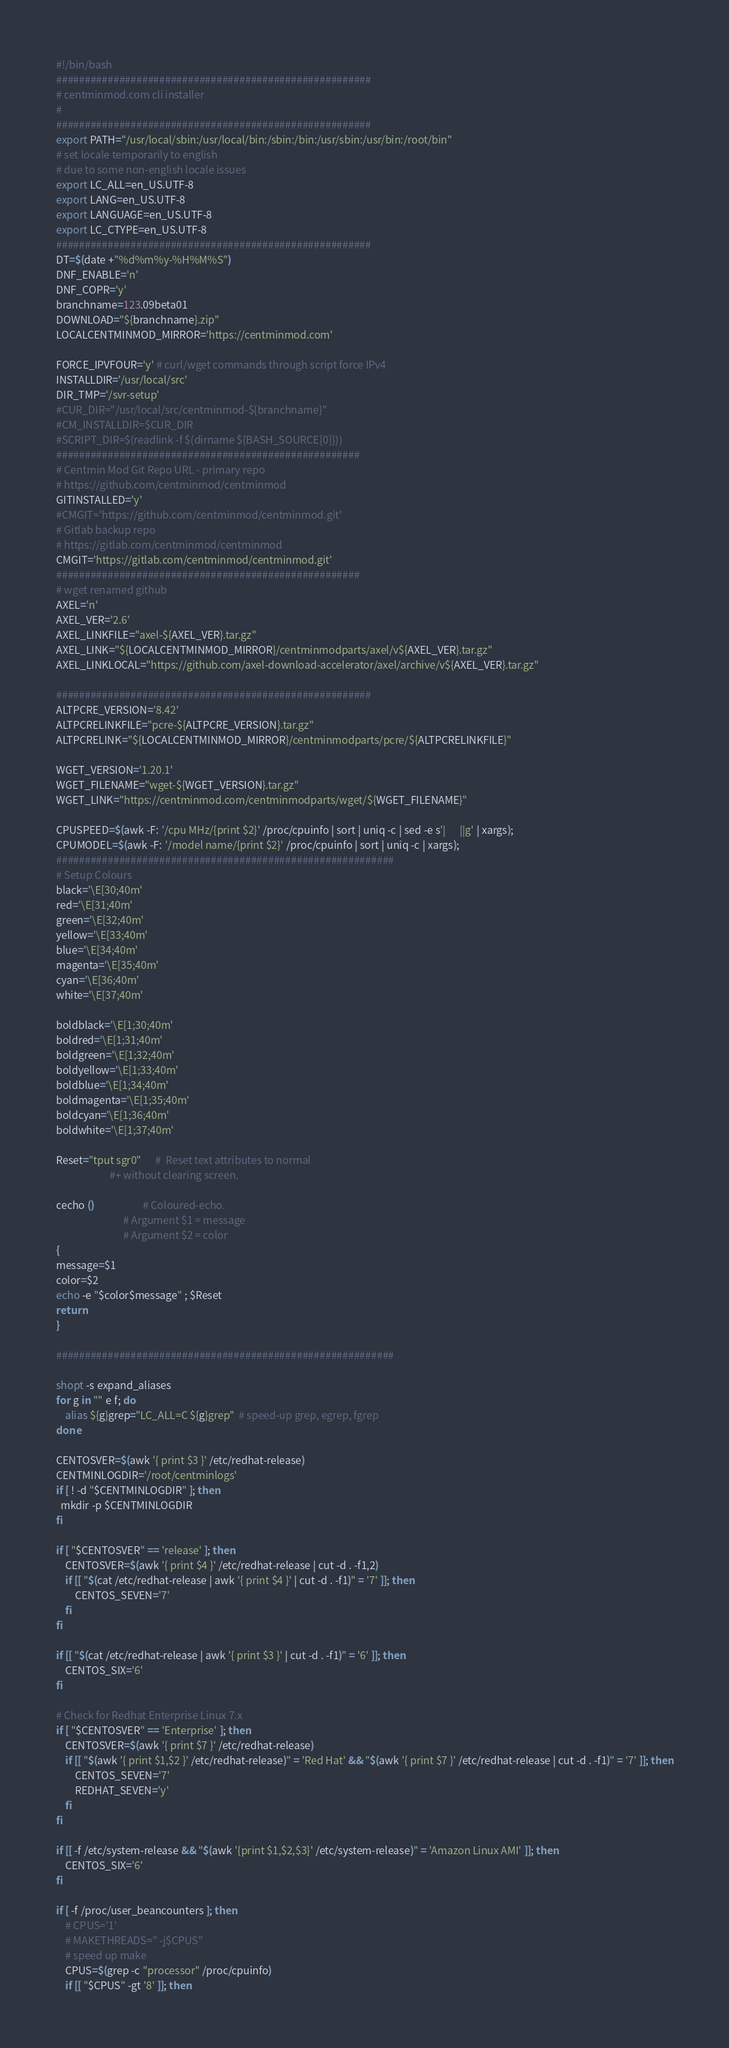Convert code to text. <code><loc_0><loc_0><loc_500><loc_500><_Bash_>#!/bin/bash
#######################################################
# centminmod.com cli installer
#
#######################################################
export PATH="/usr/local/sbin:/usr/local/bin:/sbin:/bin:/usr/sbin:/usr/bin:/root/bin"
# set locale temporarily to english
# due to some non-english locale issues
export LC_ALL=en_US.UTF-8
export LANG=en_US.UTF-8
export LANGUAGE=en_US.UTF-8
export LC_CTYPE=en_US.UTF-8
#######################################################
DT=$(date +"%d%m%y-%H%M%S")
DNF_ENABLE='n'
DNF_COPR='y'
branchname=123.09beta01
DOWNLOAD="${branchname}.zip"
LOCALCENTMINMOD_MIRROR='https://centminmod.com'

FORCE_IPVFOUR='y' # curl/wget commands through script force IPv4
INSTALLDIR='/usr/local/src'
DIR_TMP='/svr-setup'
#CUR_DIR="/usr/local/src/centminmod-${branchname}"
#CM_INSTALLDIR=$CUR_DIR
#SCRIPT_DIR=$(readlink -f $(dirname ${BASH_SOURCE[0]}))
#####################################################
# Centmin Mod Git Repo URL - primary repo
# https://github.com/centminmod/centminmod
GITINSTALLED='y'
#CMGIT='https://github.com/centminmod/centminmod.git'
# Gitlab backup repo 
# https://gitlab.com/centminmod/centminmod
CMGIT='https://gitlab.com/centminmod/centminmod.git'
#####################################################
# wget renamed github
AXEL='n'
AXEL_VER='2.6'
AXEL_LINKFILE="axel-${AXEL_VER}.tar.gz"
AXEL_LINK="${LOCALCENTMINMOD_MIRROR}/centminmodparts/axel/v${AXEL_VER}.tar.gz"
AXEL_LINKLOCAL="https://github.com/axel-download-accelerator/axel/archive/v${AXEL_VER}.tar.gz"

#######################################################
ALTPCRE_VERSION='8.42'
ALTPCRELINKFILE="pcre-${ALTPCRE_VERSION}.tar.gz"
ALTPCRELINK="${LOCALCENTMINMOD_MIRROR}/centminmodparts/pcre/${ALTPCRELINKFILE}"

WGET_VERSION='1.20.1'
WGET_FILENAME="wget-${WGET_VERSION}.tar.gz"
WGET_LINK="https://centminmod.com/centminmodparts/wget/${WGET_FILENAME}"

CPUSPEED=$(awk -F: '/cpu MHz/{print $2}' /proc/cpuinfo | sort | uniq -c | sed -e s'|      ||g' | xargs); 
CPUMODEL=$(awk -F: '/model name/{print $2}' /proc/cpuinfo | sort | uniq -c | xargs);
###########################################################
# Setup Colours
black='\E[30;40m'
red='\E[31;40m'
green='\E[32;40m'
yellow='\E[33;40m'
blue='\E[34;40m'
magenta='\E[35;40m'
cyan='\E[36;40m'
white='\E[37;40m'

boldblack='\E[1;30;40m'
boldred='\E[1;31;40m'
boldgreen='\E[1;32;40m'
boldyellow='\E[1;33;40m'
boldblue='\E[1;34;40m'
boldmagenta='\E[1;35;40m'
boldcyan='\E[1;36;40m'
boldwhite='\E[1;37;40m'

Reset="tput sgr0"      #  Reset text attributes to normal
                       #+ without clearing screen.

cecho ()                     # Coloured-echo.
                             # Argument $1 = message
                             # Argument $2 = color
{
message=$1
color=$2
echo -e "$color$message" ; $Reset
return
}

###########################################################

shopt -s expand_aliases
for g in "" e f; do
    alias ${g}grep="LC_ALL=C ${g}grep"  # speed-up grep, egrep, fgrep
done

CENTOSVER=$(awk '{ print $3 }' /etc/redhat-release)
CENTMINLOGDIR='/root/centminlogs'
if [ ! -d "$CENTMINLOGDIR" ]; then
  mkdir -p $CENTMINLOGDIR
fi

if [ "$CENTOSVER" == 'release' ]; then
    CENTOSVER=$(awk '{ print $4 }' /etc/redhat-release | cut -d . -f1,2)
    if [[ "$(cat /etc/redhat-release | awk '{ print $4 }' | cut -d . -f1)" = '7' ]]; then
        CENTOS_SEVEN='7'
    fi
fi

if [[ "$(cat /etc/redhat-release | awk '{ print $3 }' | cut -d . -f1)" = '6' ]]; then
    CENTOS_SIX='6'
fi

# Check for Redhat Enterprise Linux 7.x
if [ "$CENTOSVER" == 'Enterprise' ]; then
    CENTOSVER=$(awk '{ print $7 }' /etc/redhat-release)
    if [[ "$(awk '{ print $1,$2 }' /etc/redhat-release)" = 'Red Hat' && "$(awk '{ print $7 }' /etc/redhat-release | cut -d . -f1)" = '7' ]]; then
        CENTOS_SEVEN='7'
        REDHAT_SEVEN='y'
    fi
fi

if [[ -f /etc/system-release && "$(awk '{print $1,$2,$3}' /etc/system-release)" = 'Amazon Linux AMI' ]]; then
    CENTOS_SIX='6'
fi

if [ -f /proc/user_beancounters ]; then
    # CPUS='1'
    # MAKETHREADS=" -j$CPUS"
    # speed up make
    CPUS=$(grep -c "processor" /proc/cpuinfo)
    if [[ "$CPUS" -gt '8' ]]; then</code> 